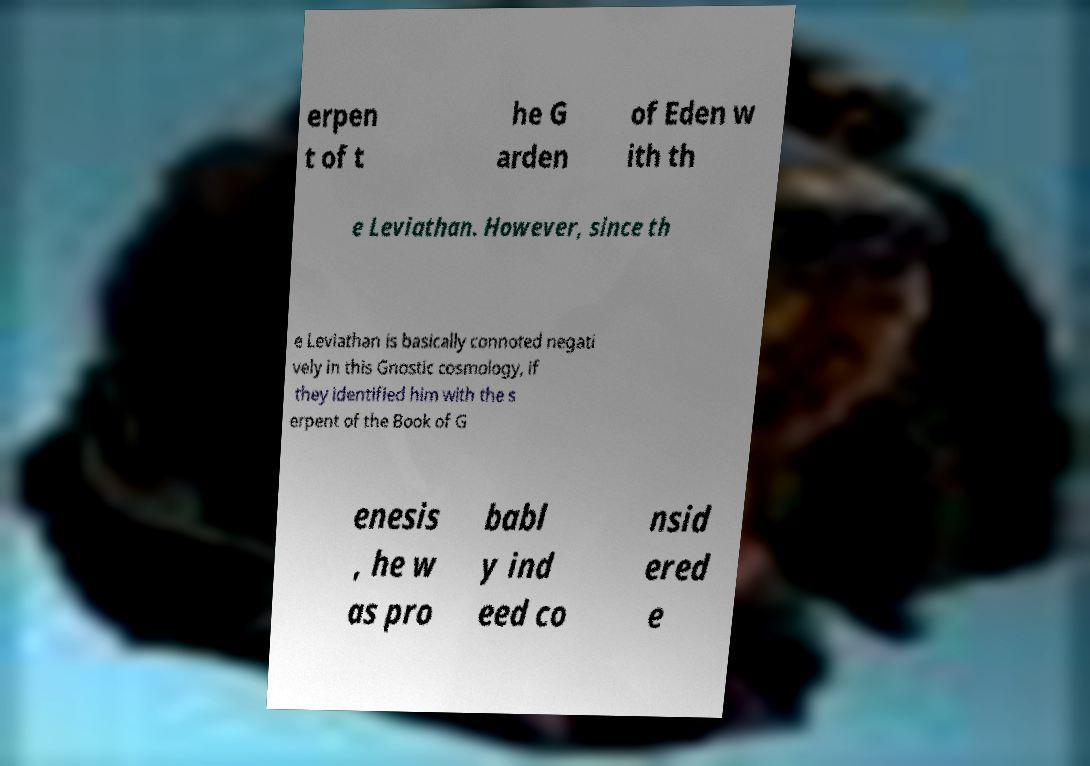Please identify and transcribe the text found in this image. erpen t of t he G arden of Eden w ith th e Leviathan. However, since th e Leviathan is basically connoted negati vely in this Gnostic cosmology, if they identified him with the s erpent of the Book of G enesis , he w as pro babl y ind eed co nsid ered e 